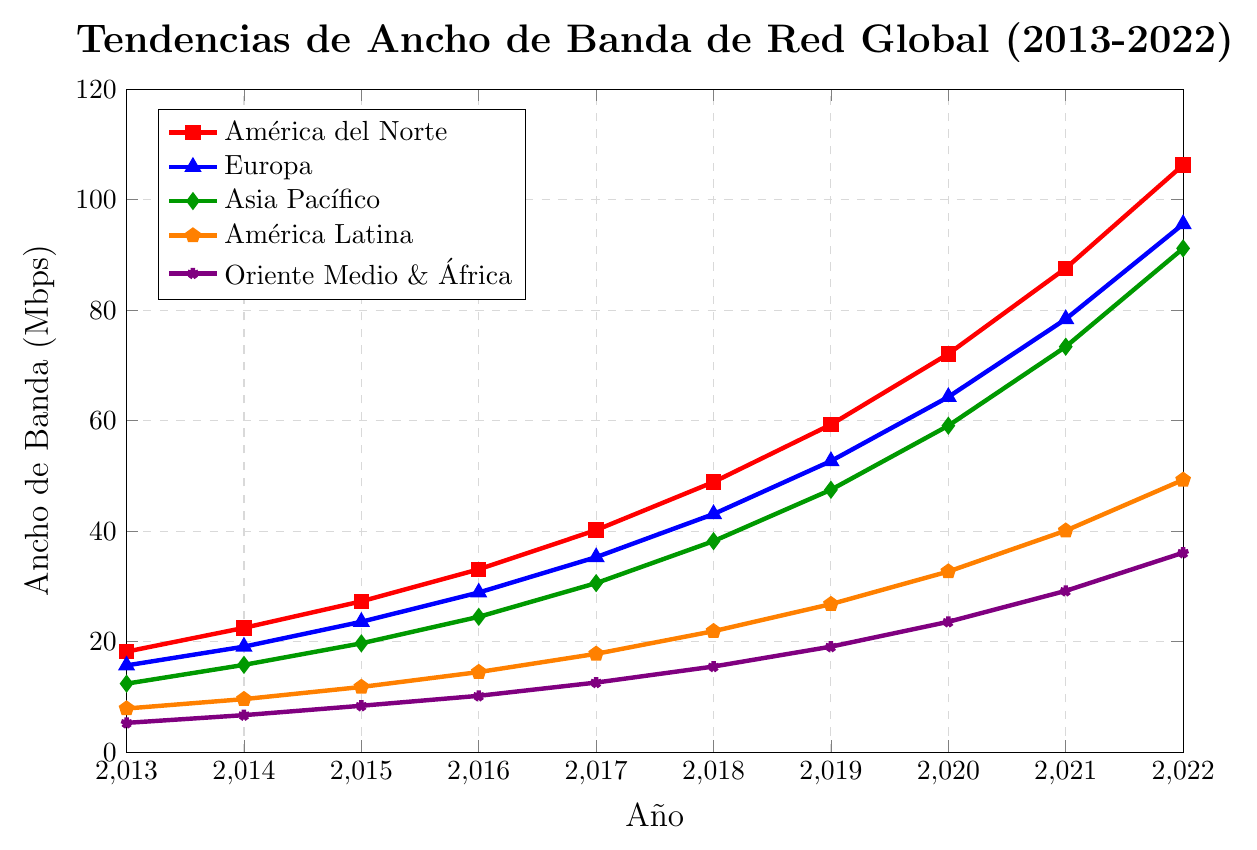¿Cuál región tuvo el mayor aumento en el ancho de banda desde 2013 hasta 2022? Compare los valores finales para cada región en el año 2022 con los valores iniciales en el año 2013 y calcule la diferencia. América del Norte tuvo un aumento de 106.3 - 18.2 = 88.1 Mbps, Europa 95.6 - 15.7 = 79.9 Mbps, Asia Pacífico 91.2 - 12.4 = 78.8 Mbps, América Latina 49.3 - 7.9 = 41.4 Mbps y Oriente Medio y África 36.1 - 5.3 = 30.8 Mbps.  Por lo tanto, América del Norte tuvo el mayor aumento en el ancho de banda con 88.1 Mbps.
Answer: América del Norte ¿Cuál año tuvo el mayor incremento en ancho de banda para la región de Asia Pacífico? Compare los incrementos año a año para Asia Pacífico: 2013 a 2014 (15.8 - 12.4 = 3.4), 2014 a 2015 (19.7 - 15.8 = 3.9), 2015 a 2016 (24.5 - 19.7 = 4.8), 2016 a 2017 (30.6 - 24.5 = 6.1), 2017 a 2018 (38.2 - 30.6 = 7.6), 2018 a 2019 (47.5 - 38.2 = 9.3), 2019 a 2020 (59.1 - 47.5 = 11.6), 2020 a 2021 (73.4 - 59.1 = 14.3), 2021 a 2022 (91.2 - 73.4 = 17.8). El mayor incremento fue de 2021 a 2022 con un aumento de 17.8 Mbps.
Answer: 2021 a 2022 En promedio, ¿qué región tuvo el mayor ancho de banda durante el periodo de 10 años? Sume los valores de ancho de banda para cada región y divídalos por el número de años: América del Norte (522.5/10 = 52.25), Europa (455.9/10 = 45.59), Asia Pacífico (411.4/10 = 41.14), América Latina (253.5/10 = 25.35), Oriente Medio y África (186.7/10 = 18.67). América del Norte tuvo el mayor promedio con 52.25 Mbps.
Answer: América del Norte ¿En qué año Europa superó los 50 Mbps de ancho de banda? Observe los valores de ancho de banda para Europa y encuentre el primer año en que el valor supera los 50 Mbps: 2019 (52.7 Mbps).
Answer: 2019 ¿Cuál región mostró el menor crecimiento relativo en ancho de banda desde 2013 hasta 2022? Calcule el crecimiento relativo para cada región dividiendo el aumento total por el valor de 2013: América del Norte (88.1 / 18.2 ≈ 4.84), Europa (79.9 / 15.7 ≈ 5.09), Asia Pacífico (78.8 / 12.4 ≈ 6.36), América Latina (41.4 / 7.9 ≈ 5.24), Oriente Medio y África (30.8 / 5.3 ≈ 5.81). Oriente Medio y África mostró el menor crecimiento relativo con un factor de aproximadamente 5.81.
Answer: Oriente Medio y África 